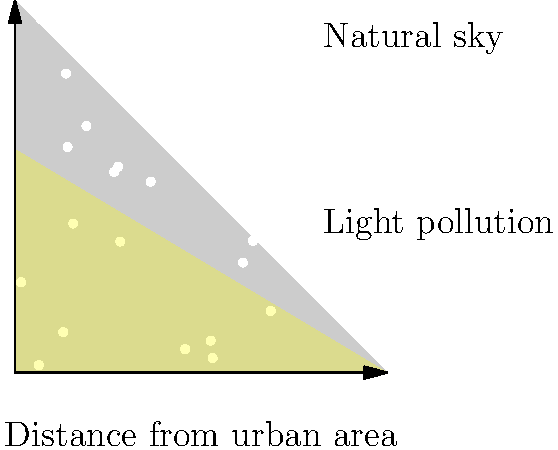Based on the sky glow diagram, how might increasing light pollution affect the foraging behavior of nocturnal wildlife in urban-adjacent natural areas? To answer this question, let's consider the impact of light pollution on nocturnal wildlife step-by-step:

1. Light pollution effect: The diagram shows how light pollution from urban areas creates a "sky glow" that extends into natural areas, increasing overall sky brightness.

2. Nocturnal adaptations: Many nocturnal animals have evolved to be active in low-light conditions, with adaptations such as enhanced night vision and reliance on darkness for camouflage.

3. Disruption of natural light cycles: Increased sky brightness can mimic twilight or even daytime conditions, potentially confusing animals' circadian rhythms and natural behavior patterns.

4. Predator-prey dynamics: Increased illumination can make prey species more visible to predators, altering the balance of predator-prey interactions.

5. Foraging behavior changes:
   a) Reduced foraging time: Some nocturnal animals may perceive the environment as less safe due to increased visibility, leading to shorter foraging periods.
   b) Shift in foraging areas: Animals might avoid brightly lit areas, concentrating their activities in darker regions further from urban edges.
   c) Altered food availability: Changes in insect behavior due to artificial light can affect the food supply for insectivorous species.

6. Competitive advantage: Some species may adapt better to increased light levels, potentially outcompeting more light-sensitive species.

7. Energy expenditure: Animals may need to travel further to find suitable dark foraging areas, increasing energy costs.

These factors combine to suggest that increasing light pollution would likely lead to significant changes in the foraging patterns of nocturnal wildlife, potentially reducing their feeding efficiency and altering ecosystem dynamics in urban-adjacent natural areas.
Answer: Reduced and shifted foraging activity 